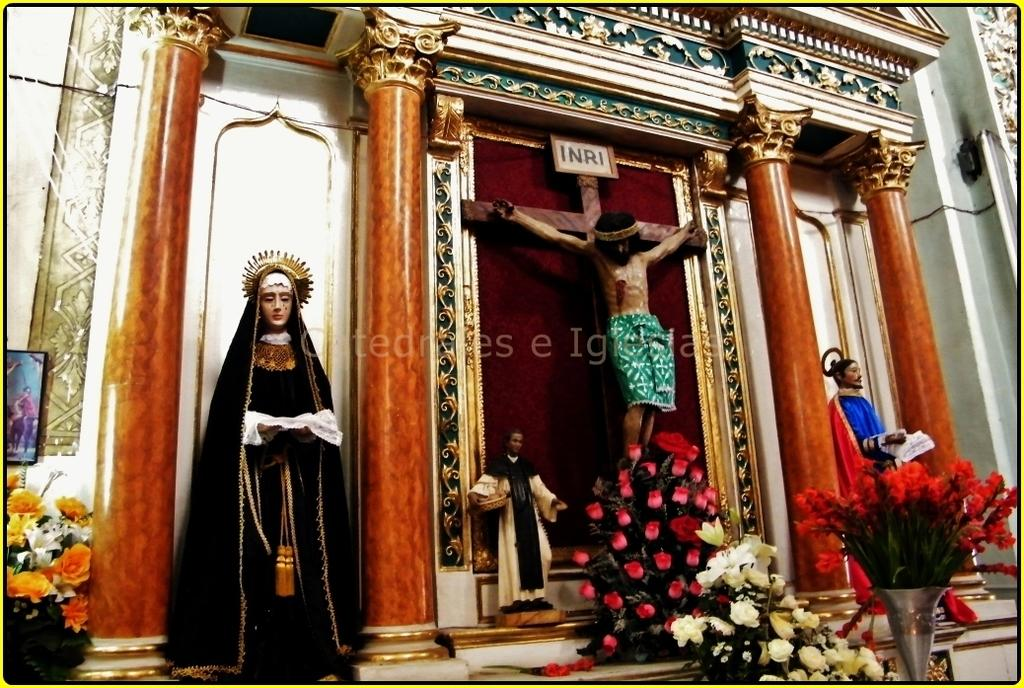Provide a one-sentence caption for the provided image. A scene with Jesus on a cross and INRI written above his head. 